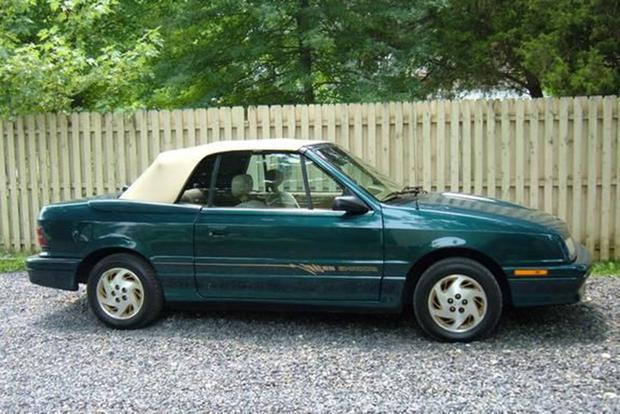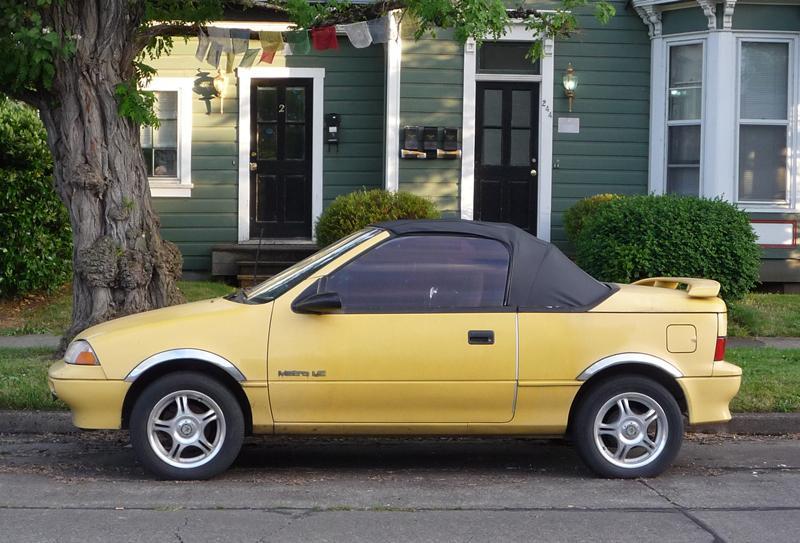The first image is the image on the left, the second image is the image on the right. Considering the images on both sides, is "An image shows a yellow car parked and facing leftward." valid? Answer yes or no. Yes. The first image is the image on the left, the second image is the image on the right. Evaluate the accuracy of this statement regarding the images: "The car on the right has its top down.". Is it true? Answer yes or no. No. 